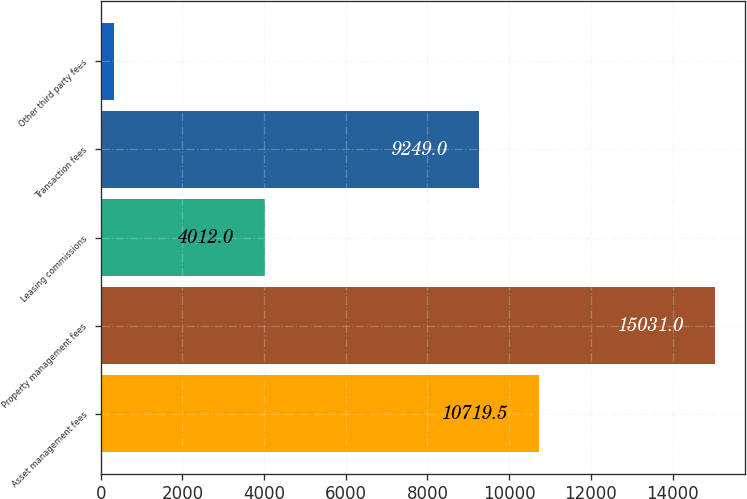Convert chart. <chart><loc_0><loc_0><loc_500><loc_500><bar_chart><fcel>Asset management fees<fcel>Property management fees<fcel>Leasing commissions<fcel>Transaction fees<fcel>Other third party fees<nl><fcel>10719.5<fcel>15031<fcel>4012<fcel>9249<fcel>326<nl></chart> 